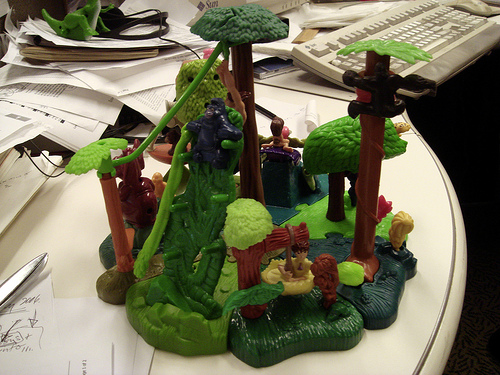<image>
Is the scissors under the monkey? No. The scissors is not positioned under the monkey. The vertical relationship between these objects is different. 